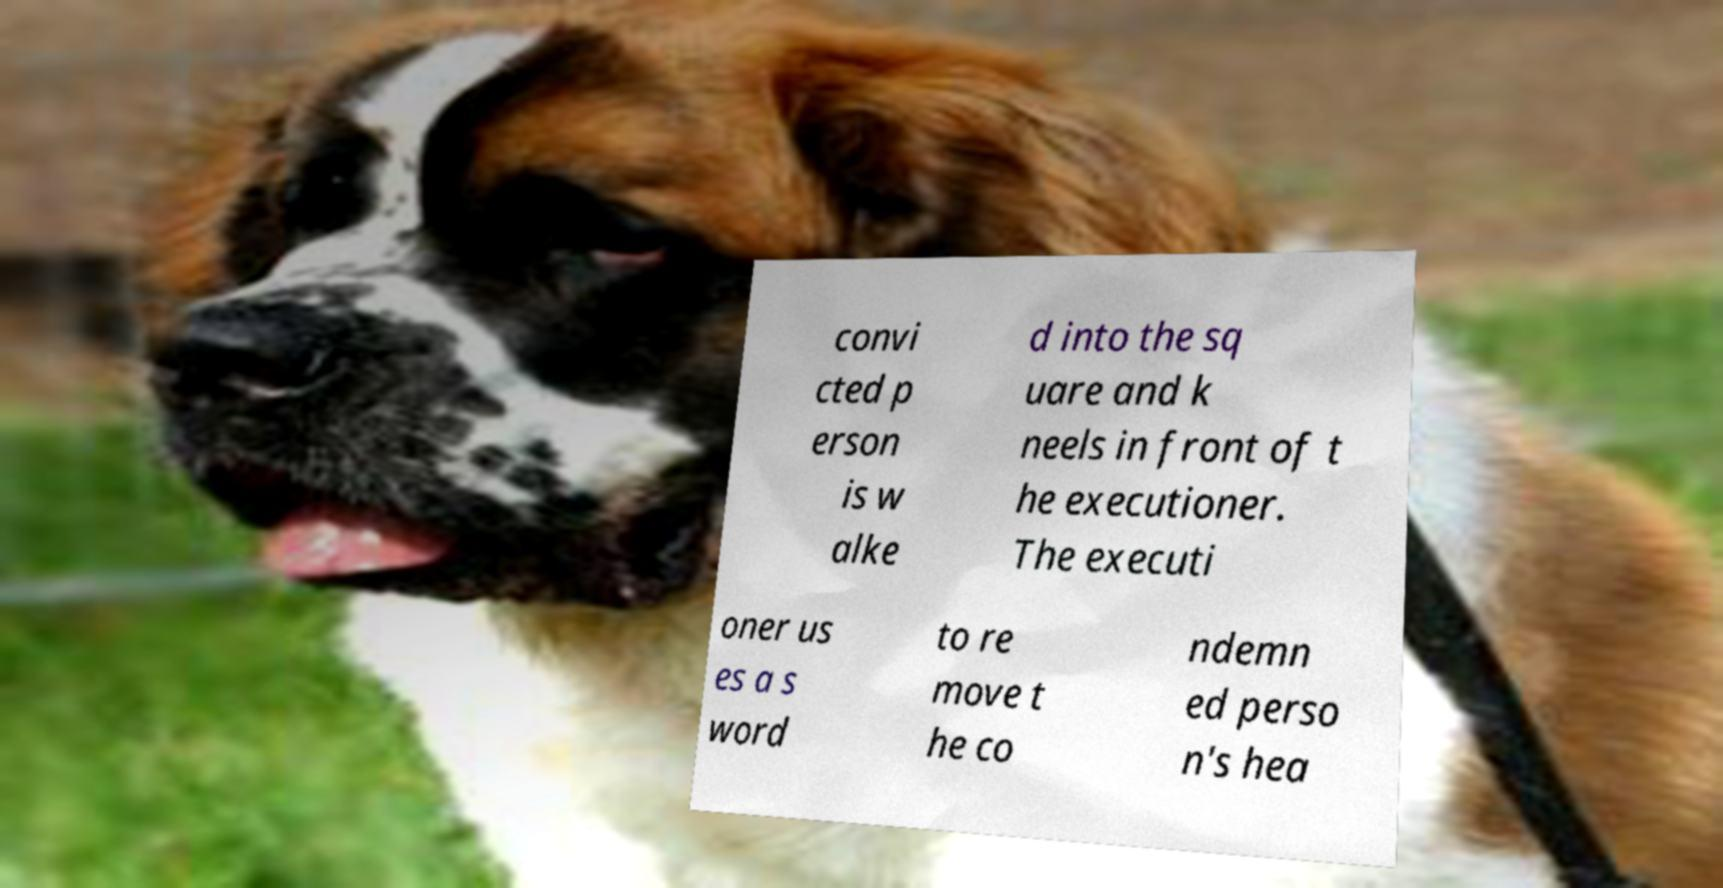Can you accurately transcribe the text from the provided image for me? convi cted p erson is w alke d into the sq uare and k neels in front of t he executioner. The executi oner us es a s word to re move t he co ndemn ed perso n's hea 